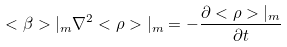Convert formula to latex. <formula><loc_0><loc_0><loc_500><loc_500>< \beta > | _ { m } \nabla ^ { 2 } < \rho > | _ { m } = - \frac { \partial < \rho > | _ { m } } { \partial t }</formula> 